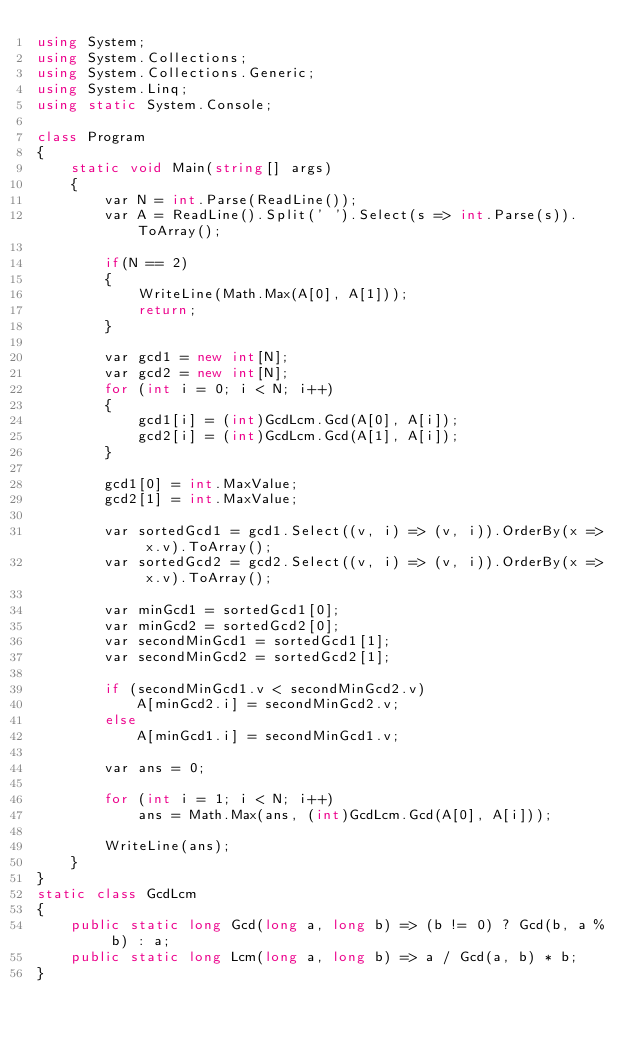Convert code to text. <code><loc_0><loc_0><loc_500><loc_500><_C#_>using System;
using System.Collections;
using System.Collections.Generic;
using System.Linq;
using static System.Console;

class Program
{
    static void Main(string[] args)
    {
        var N = int.Parse(ReadLine());
        var A = ReadLine().Split(' ').Select(s => int.Parse(s)).ToArray();

        if(N == 2)
        {
            WriteLine(Math.Max(A[0], A[1]));
            return;
        }

        var gcd1 = new int[N];
        var gcd2 = new int[N];
        for (int i = 0; i < N; i++)
        {
            gcd1[i] = (int)GcdLcm.Gcd(A[0], A[i]);
            gcd2[i] = (int)GcdLcm.Gcd(A[1], A[i]);
        }

        gcd1[0] = int.MaxValue;
        gcd2[1] = int.MaxValue;

        var sortedGcd1 = gcd1.Select((v, i) => (v, i)).OrderBy(x => x.v).ToArray();
        var sortedGcd2 = gcd2.Select((v, i) => (v, i)).OrderBy(x => x.v).ToArray();

        var minGcd1 = sortedGcd1[0];
        var minGcd2 = sortedGcd2[0];
        var secondMinGcd1 = sortedGcd1[1];
        var secondMinGcd2 = sortedGcd2[1];

        if (secondMinGcd1.v < secondMinGcd2.v)
            A[minGcd2.i] = secondMinGcd2.v;
        else
            A[minGcd1.i] = secondMinGcd1.v;

        var ans = 0;

        for (int i = 1; i < N; i++)
            ans = Math.Max(ans, (int)GcdLcm.Gcd(A[0], A[i]));

        WriteLine(ans);
    }
}
static class GcdLcm
{
    public static long Gcd(long a, long b) => (b != 0) ? Gcd(b, a % b) : a;
    public static long Lcm(long a, long b) => a / Gcd(a, b) * b;
}
</code> 